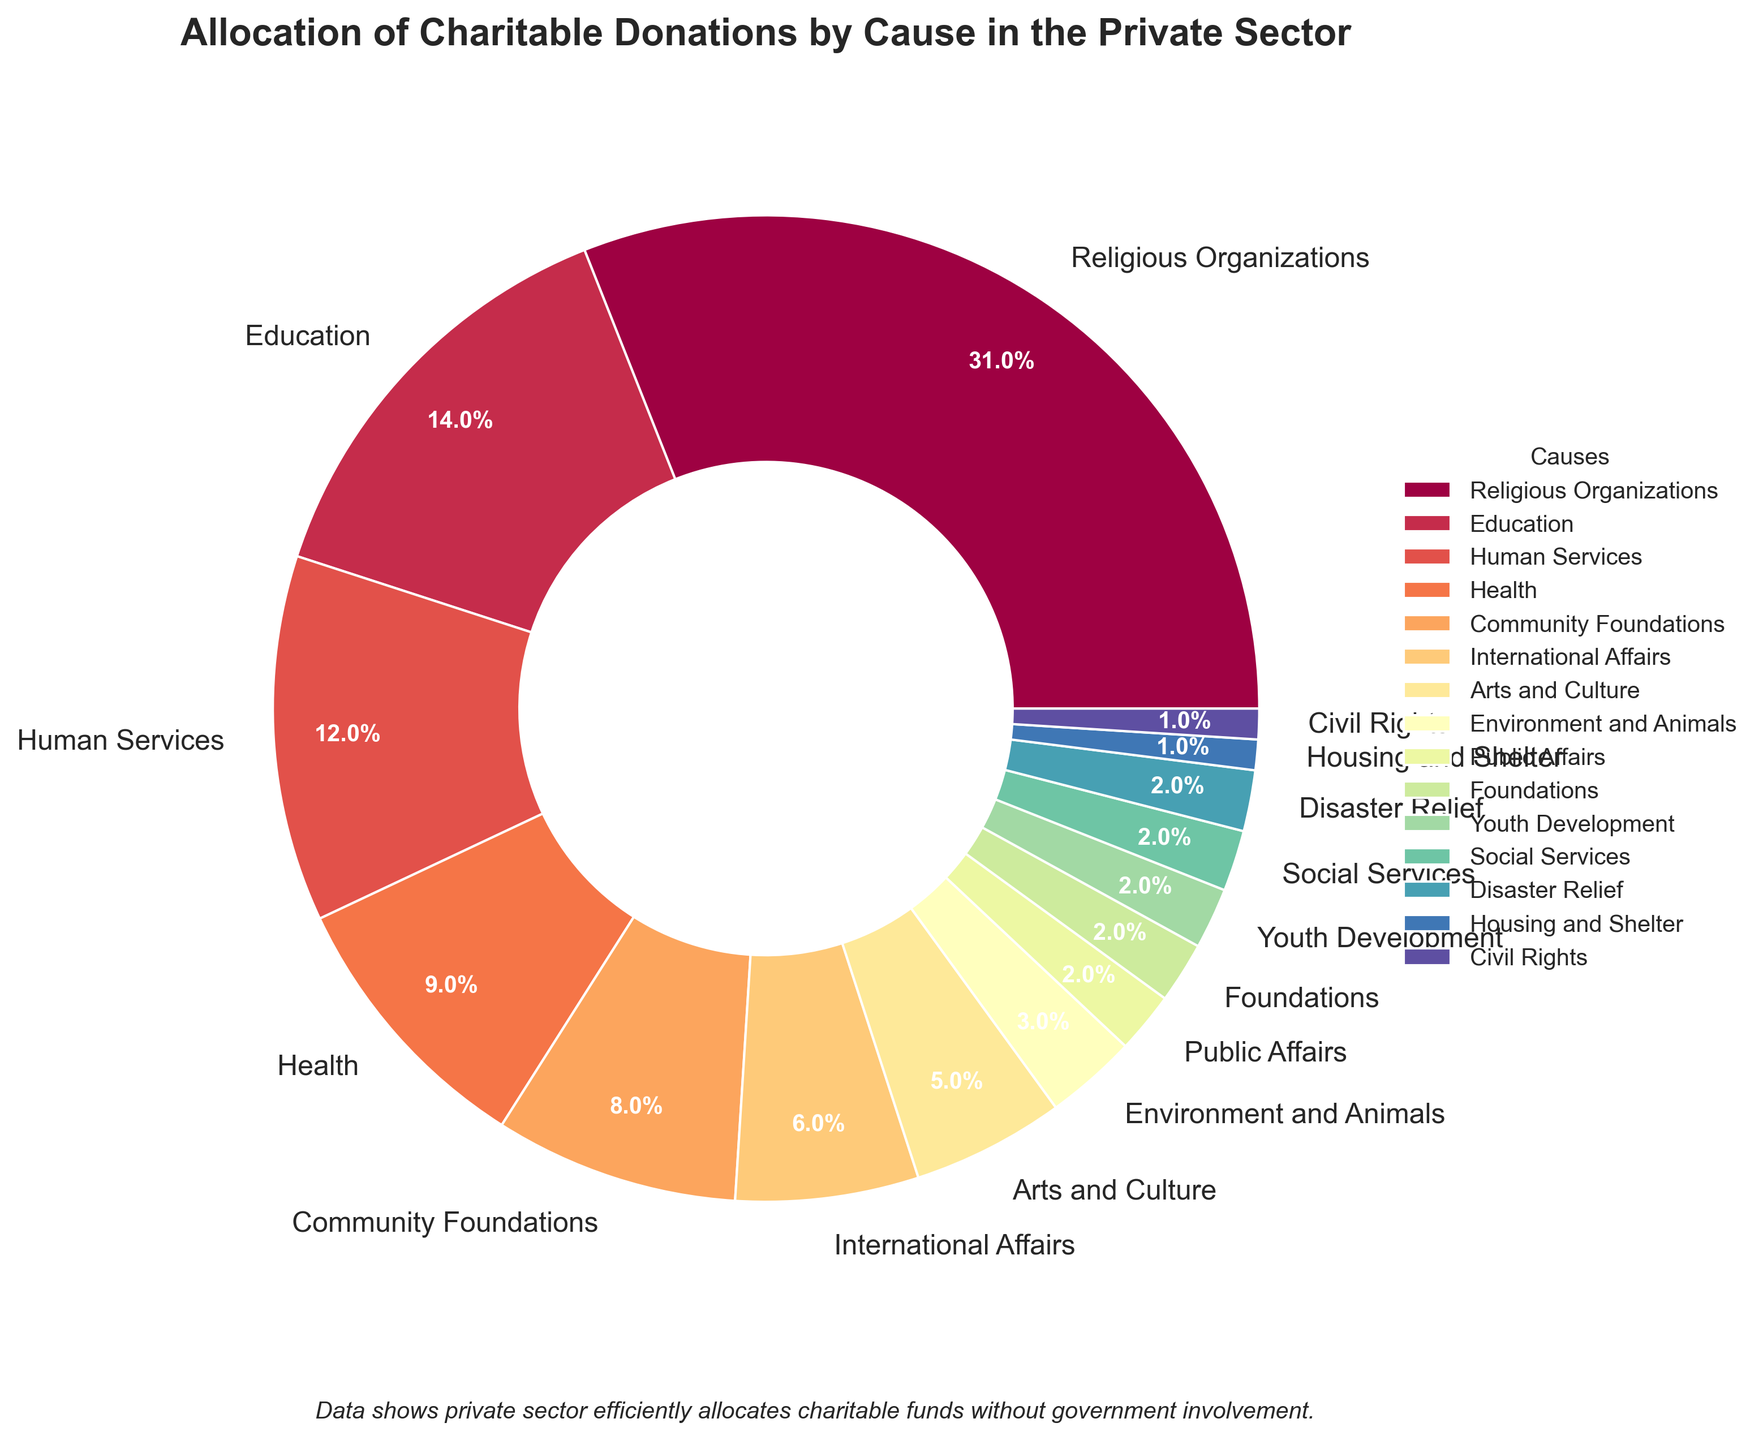Which cause gets the largest allocation of charitable donations? Look at the pie chart and identify the segment with the largest percentage. The largest segment is labeled "Religious Organizations" with 31%.
Answer: Religious Organizations What is the combined percentage of donations to Education and Health? Find the donation percentages for Education and Health from the chart, which are 14% and 9% respectively. Add them together: 14% + 9% = 23%.
Answer: 23% Do donations to the Arts and Culture exceed those to Environment and Animals? Compare the percentages for Arts and Culture (5%) and Environment and Animals (3%). Since 5% is greater than 3%, donations to Arts and Culture do exceed those to Environment and Animals.
Answer: Yes Which three causes receive the smallest percentages of charitable donations? Look at the pie chart and identify the three segments with the smallest contiguous percentages. These are Housing and Shelter (1%), Civil Rights (1%), and Disaster Relief (2%).
Answer: Housing and Shelter, Civil Rights, Disaster Relief How much more percentage does Human Services receive compared to International Affairs? Find the donation percentages for Human Services and International Affairs, which are 12% and 6% respectively. Subtract the percentage for International Affairs from that for Human Services: 12% - 6% = 6%.
Answer: 6% What is the total percentage of donations going to causes other than Religious Organizations? Subtract the percentage for Religious Organizations from 100%: 100% - 31% = 69%.
Answer: 69% How does the percentage for Community Foundations compare to that for Education? Compare the percentages for Community Foundations (8%) and Education (14%). Community Foundations receive fewer donations than Education.
Answer: Less What percentage difference is there between donations to Health and Human Services? Subtract the percentage for Health (9%) from Human Services (12%): 12% - 9% = 3%.
Answer: 3% Which cause receives more: Youth Development, Public Affairs, or Social Services? Compare the donation percentages for Youth Development, Public Affairs, and Social Services, which are all 2%. Since they are equal, none receives more than the others.
Answer: Equal Is the percentage of donations to Disaster Relief greater than that to Housing and Shelter? Compare the percentages for Disaster Relief (2%) and Housing and Shelter (1%). Since 2% is greater than 1%, Disaster Relief receives more donations.
Answer: Yes 